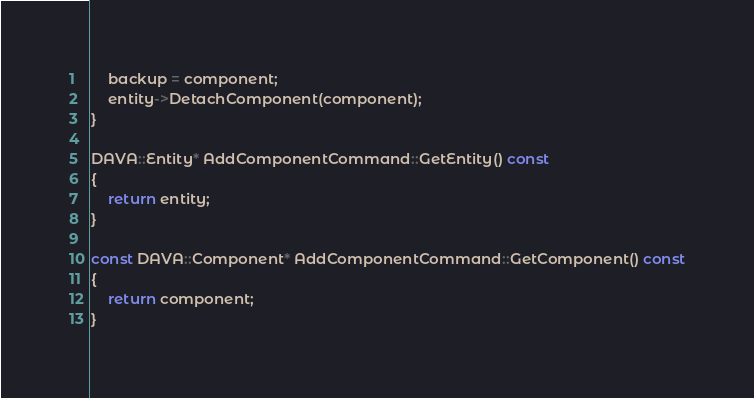<code> <loc_0><loc_0><loc_500><loc_500><_C++_>    backup = component;
    entity->DetachComponent(component);
}

DAVA::Entity* AddComponentCommand::GetEntity() const
{
    return entity;
}

const DAVA::Component* AddComponentCommand::GetComponent() const
{
    return component;
}
</code> 